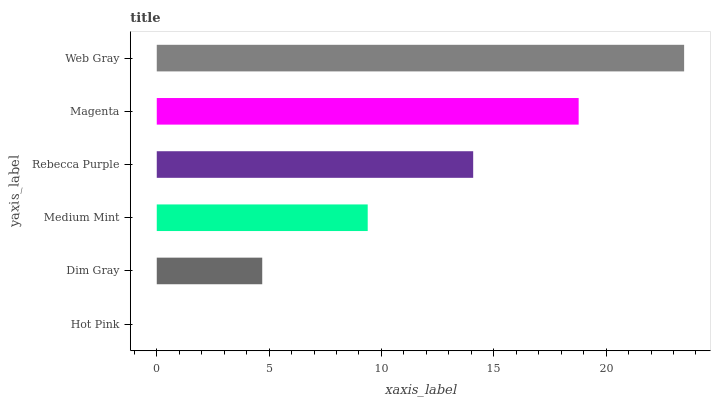Is Hot Pink the minimum?
Answer yes or no. Yes. Is Web Gray the maximum?
Answer yes or no. Yes. Is Dim Gray the minimum?
Answer yes or no. No. Is Dim Gray the maximum?
Answer yes or no. No. Is Dim Gray greater than Hot Pink?
Answer yes or no. Yes. Is Hot Pink less than Dim Gray?
Answer yes or no. Yes. Is Hot Pink greater than Dim Gray?
Answer yes or no. No. Is Dim Gray less than Hot Pink?
Answer yes or no. No. Is Rebecca Purple the high median?
Answer yes or no. Yes. Is Medium Mint the low median?
Answer yes or no. Yes. Is Hot Pink the high median?
Answer yes or no. No. Is Magenta the low median?
Answer yes or no. No. 